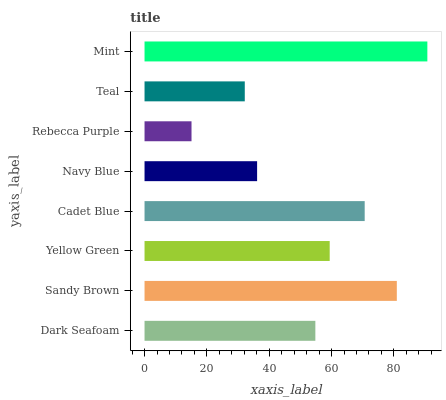Is Rebecca Purple the minimum?
Answer yes or no. Yes. Is Mint the maximum?
Answer yes or no. Yes. Is Sandy Brown the minimum?
Answer yes or no. No. Is Sandy Brown the maximum?
Answer yes or no. No. Is Sandy Brown greater than Dark Seafoam?
Answer yes or no. Yes. Is Dark Seafoam less than Sandy Brown?
Answer yes or no. Yes. Is Dark Seafoam greater than Sandy Brown?
Answer yes or no. No. Is Sandy Brown less than Dark Seafoam?
Answer yes or no. No. Is Yellow Green the high median?
Answer yes or no. Yes. Is Dark Seafoam the low median?
Answer yes or no. Yes. Is Cadet Blue the high median?
Answer yes or no. No. Is Yellow Green the low median?
Answer yes or no. No. 